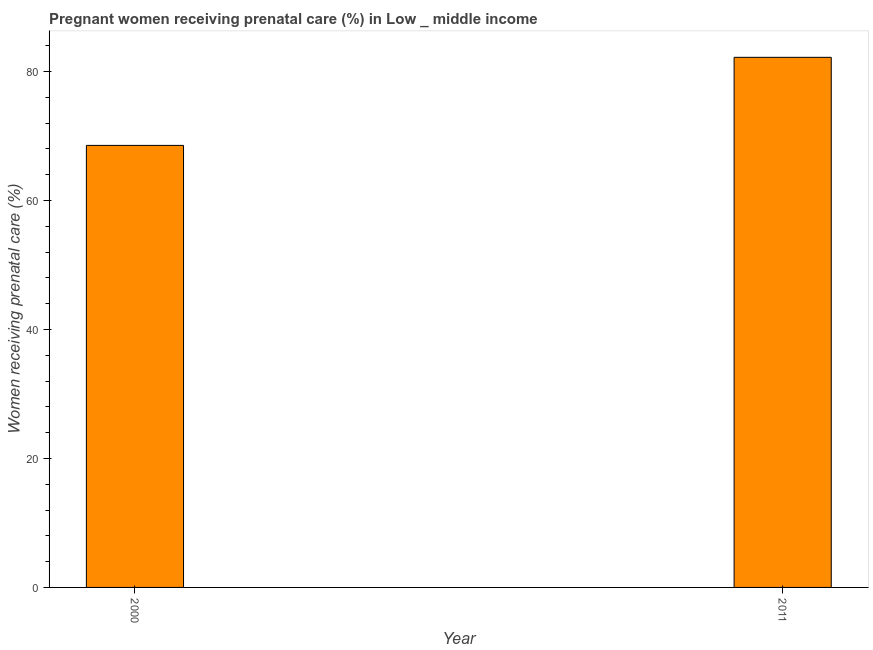Does the graph contain grids?
Give a very brief answer. No. What is the title of the graph?
Ensure brevity in your answer.  Pregnant women receiving prenatal care (%) in Low _ middle income. What is the label or title of the Y-axis?
Provide a succinct answer. Women receiving prenatal care (%). What is the percentage of pregnant women receiving prenatal care in 2011?
Give a very brief answer. 82.2. Across all years, what is the maximum percentage of pregnant women receiving prenatal care?
Give a very brief answer. 82.2. Across all years, what is the minimum percentage of pregnant women receiving prenatal care?
Offer a terse response. 68.54. In which year was the percentage of pregnant women receiving prenatal care maximum?
Your answer should be very brief. 2011. In which year was the percentage of pregnant women receiving prenatal care minimum?
Make the answer very short. 2000. What is the sum of the percentage of pregnant women receiving prenatal care?
Offer a terse response. 150.74. What is the difference between the percentage of pregnant women receiving prenatal care in 2000 and 2011?
Offer a terse response. -13.66. What is the average percentage of pregnant women receiving prenatal care per year?
Your response must be concise. 75.37. What is the median percentage of pregnant women receiving prenatal care?
Your answer should be compact. 75.37. What is the ratio of the percentage of pregnant women receiving prenatal care in 2000 to that in 2011?
Provide a succinct answer. 0.83. Is the percentage of pregnant women receiving prenatal care in 2000 less than that in 2011?
Provide a short and direct response. Yes. Are all the bars in the graph horizontal?
Provide a succinct answer. No. What is the difference between two consecutive major ticks on the Y-axis?
Provide a succinct answer. 20. Are the values on the major ticks of Y-axis written in scientific E-notation?
Ensure brevity in your answer.  No. What is the Women receiving prenatal care (%) in 2000?
Your answer should be compact. 68.54. What is the Women receiving prenatal care (%) of 2011?
Offer a terse response. 82.2. What is the difference between the Women receiving prenatal care (%) in 2000 and 2011?
Make the answer very short. -13.66. What is the ratio of the Women receiving prenatal care (%) in 2000 to that in 2011?
Ensure brevity in your answer.  0.83. 